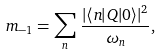Convert formula to latex. <formula><loc_0><loc_0><loc_500><loc_500>m _ { - 1 } = \sum _ { n } \, \frac { | \langle n | Q | 0 \rangle | ^ { 2 } } { \omega _ { n } } ,</formula> 